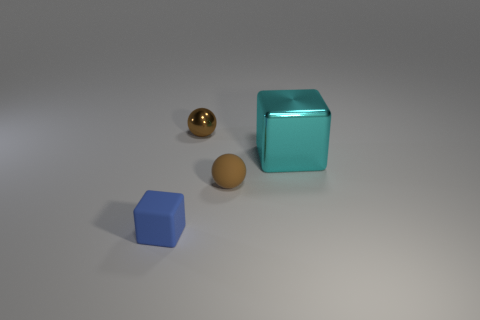What is the material of the small thing that is to the left of the brown rubber object and behind the blue thing? The small object to the left of the brown spherical object, which appears to be made of rubber, and behind the blue cube, seems to be metallic due to its reflective surface and golden color. 